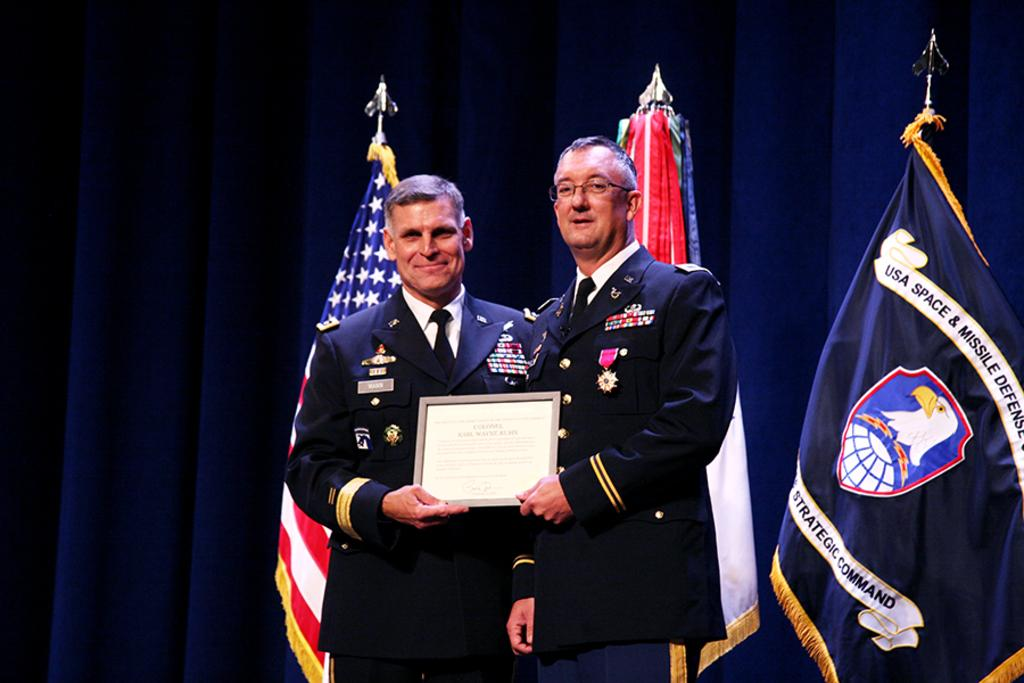<image>
Render a clear and concise summary of the photo. Two patriots posing for a picture with a flag for the USA Space & Missile Defense in the background. 